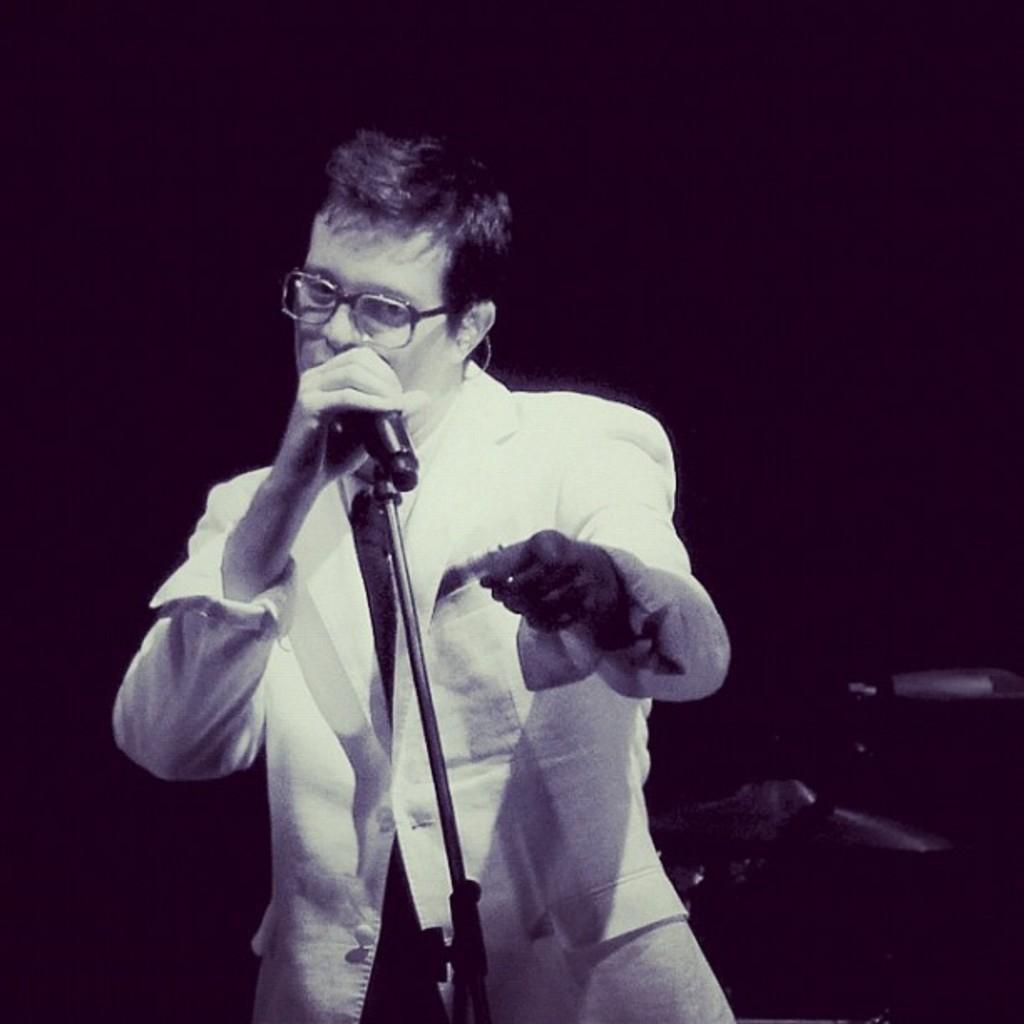Describe this image in one or two sentences. This is the picture of black and white image where we can see a person holding a microphone. 